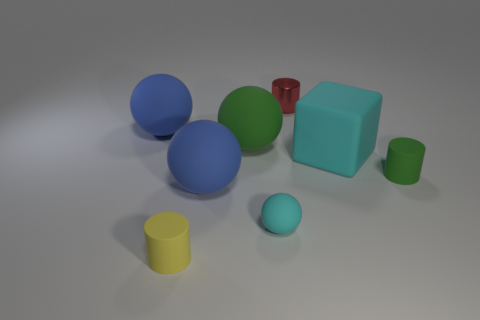Is there any other thing that is the same color as the matte cube? Yes, the smaller cube towards the front appears to share the same matte teal color as the larger cube in the center. 